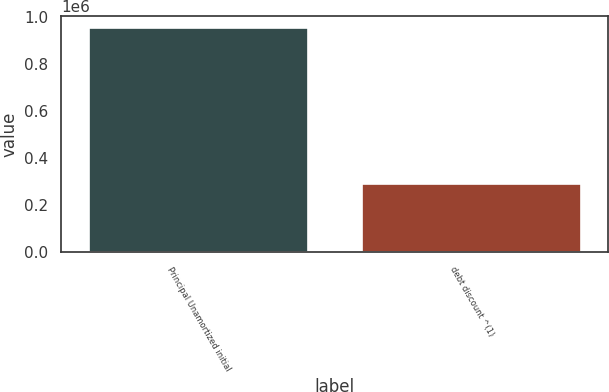Convert chart. <chart><loc_0><loc_0><loc_500><loc_500><bar_chart><fcel>Principal Unamortized initial<fcel>debt discount ^(1)<nl><fcel>954000<fcel>287876<nl></chart> 